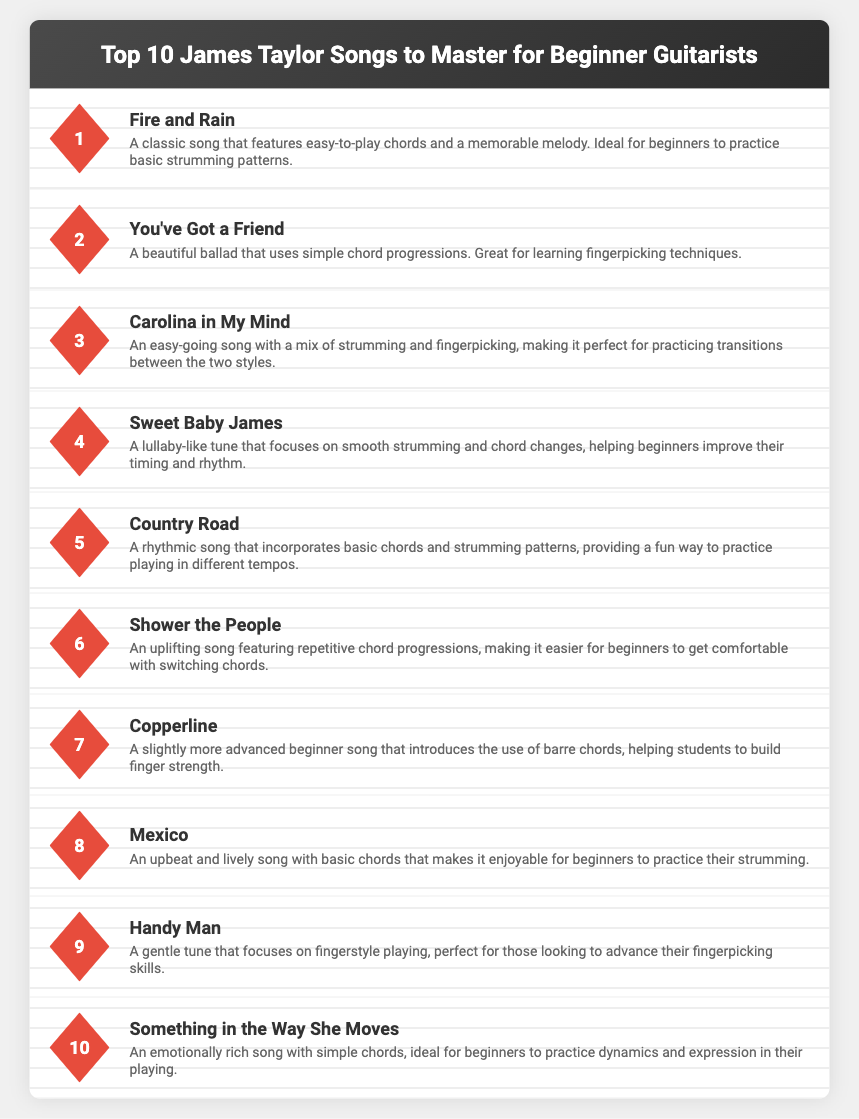What is the title of the infographic? The title is prominently displayed at the top of the document, indicating the primary focus of the content.
Answer: Top 10 James Taylor Songs to Master for Beginner Guitarists How many songs are listed in the infographic? The document explicitly states the ranking of the songs, which indicates the total number included.
Answer: 10 What is the first song mentioned in the list? The song at the top of the list represents the first entry, providing a clear indication of its position.
Answer: Fire and Rain What chord technique is highlighted in "You've Got a Friend"? The description for this song emphasizes the learning of a particular guitar technique beneficial for beginners.
Answer: Fingerpicking techniques Which song features barre chords? The document specifies a song that introduces barre chords, which is a more advanced topic for beginners.
Answer: Copperline What is the focus of "Handy Man"? The description reveals the key area of practice for this particular song, aimed at fostering specific skills.
Answer: Fingerstyle playing Which song provides an opportunity to practice dynamics and expression? The details outline that one song is specifically suited for exploring emotional playing techniques.
Answer: Something in the Way She Moves What type of song is "Fire and Rain"? The description categorizes this song based on its musical style and chord complexity for beginners.
Answer: Classic Which song is described as a lullaby-like tune? The descriptive details reveal a song that has qualities resembling that of a lullaby.
Answer: Sweet Baby James 